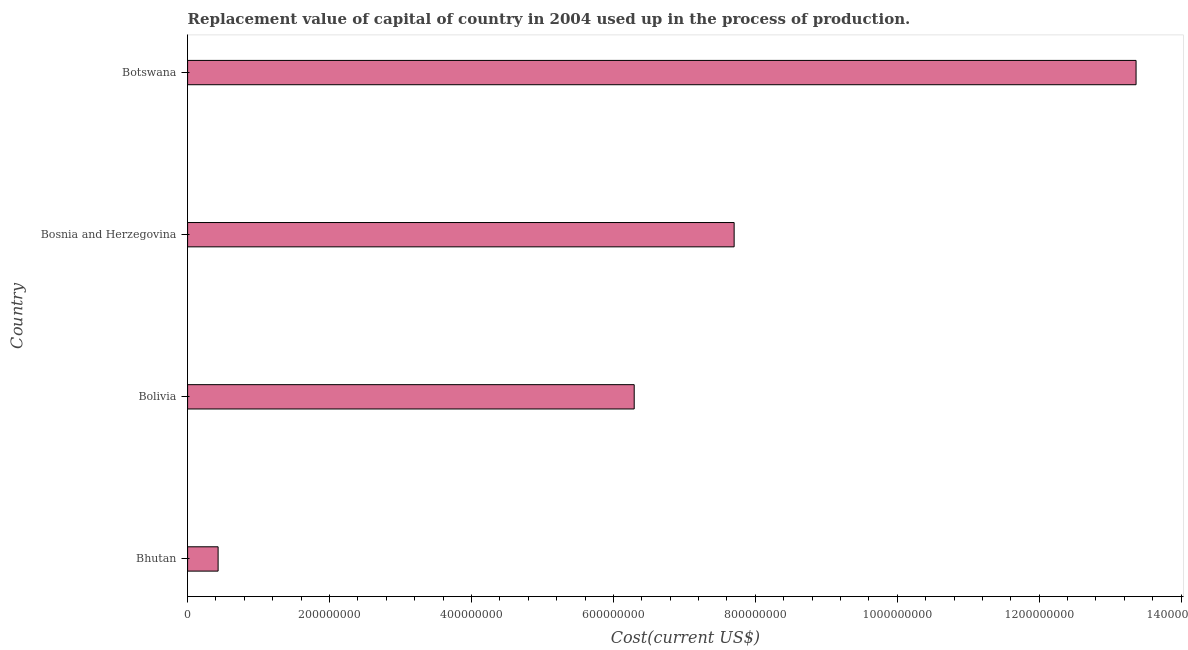Does the graph contain grids?
Offer a very short reply. No. What is the title of the graph?
Your answer should be very brief. Replacement value of capital of country in 2004 used up in the process of production. What is the label or title of the X-axis?
Offer a very short reply. Cost(current US$). What is the label or title of the Y-axis?
Your response must be concise. Country. What is the consumption of fixed capital in Bolivia?
Ensure brevity in your answer.  6.29e+08. Across all countries, what is the maximum consumption of fixed capital?
Provide a short and direct response. 1.34e+09. Across all countries, what is the minimum consumption of fixed capital?
Ensure brevity in your answer.  4.30e+07. In which country was the consumption of fixed capital maximum?
Provide a succinct answer. Botswana. In which country was the consumption of fixed capital minimum?
Give a very brief answer. Bhutan. What is the sum of the consumption of fixed capital?
Provide a short and direct response. 2.78e+09. What is the difference between the consumption of fixed capital in Bolivia and Botswana?
Your response must be concise. -7.07e+08. What is the average consumption of fixed capital per country?
Provide a succinct answer. 6.95e+08. What is the median consumption of fixed capital?
Ensure brevity in your answer.  7.00e+08. In how many countries, is the consumption of fixed capital greater than 760000000 US$?
Offer a very short reply. 2. What is the ratio of the consumption of fixed capital in Bolivia to that in Botswana?
Make the answer very short. 0.47. Is the difference between the consumption of fixed capital in Bolivia and Botswana greater than the difference between any two countries?
Provide a short and direct response. No. What is the difference between the highest and the second highest consumption of fixed capital?
Give a very brief answer. 5.66e+08. Is the sum of the consumption of fixed capital in Bolivia and Botswana greater than the maximum consumption of fixed capital across all countries?
Provide a short and direct response. Yes. What is the difference between the highest and the lowest consumption of fixed capital?
Provide a succinct answer. 1.29e+09. How many countries are there in the graph?
Ensure brevity in your answer.  4. What is the difference between two consecutive major ticks on the X-axis?
Keep it short and to the point. 2.00e+08. What is the Cost(current US$) of Bhutan?
Give a very brief answer. 4.30e+07. What is the Cost(current US$) in Bolivia?
Your answer should be very brief. 6.29e+08. What is the Cost(current US$) of Bosnia and Herzegovina?
Offer a very short reply. 7.70e+08. What is the Cost(current US$) of Botswana?
Make the answer very short. 1.34e+09. What is the difference between the Cost(current US$) in Bhutan and Bolivia?
Provide a short and direct response. -5.86e+08. What is the difference between the Cost(current US$) in Bhutan and Bosnia and Herzegovina?
Your answer should be compact. -7.27e+08. What is the difference between the Cost(current US$) in Bhutan and Botswana?
Provide a short and direct response. -1.29e+09. What is the difference between the Cost(current US$) in Bolivia and Bosnia and Herzegovina?
Your answer should be very brief. -1.41e+08. What is the difference between the Cost(current US$) in Bolivia and Botswana?
Your answer should be compact. -7.07e+08. What is the difference between the Cost(current US$) in Bosnia and Herzegovina and Botswana?
Your answer should be very brief. -5.66e+08. What is the ratio of the Cost(current US$) in Bhutan to that in Bolivia?
Provide a short and direct response. 0.07. What is the ratio of the Cost(current US$) in Bhutan to that in Bosnia and Herzegovina?
Give a very brief answer. 0.06. What is the ratio of the Cost(current US$) in Bhutan to that in Botswana?
Give a very brief answer. 0.03. What is the ratio of the Cost(current US$) in Bolivia to that in Bosnia and Herzegovina?
Offer a terse response. 0.82. What is the ratio of the Cost(current US$) in Bolivia to that in Botswana?
Make the answer very short. 0.47. What is the ratio of the Cost(current US$) in Bosnia and Herzegovina to that in Botswana?
Provide a short and direct response. 0.58. 